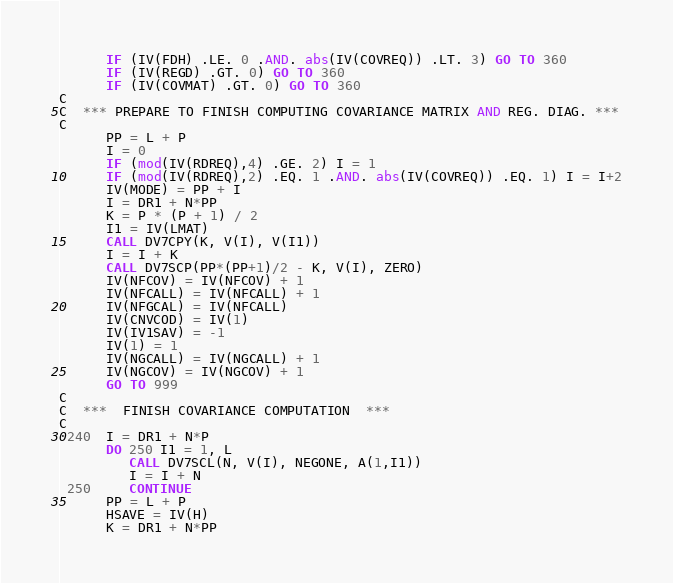Convert code to text. <code><loc_0><loc_0><loc_500><loc_500><_FORTRAN_>      IF (IV(FDH) .LE. 0 .AND. abs(IV(COVREQ)) .LT. 3) GO TO 360
      IF (IV(REGD) .GT. 0) GO TO 360
      IF (IV(COVMAT) .GT. 0) GO TO 360
C
C  *** PREPARE TO FINISH COMPUTING COVARIANCE MATRIX AND REG. DIAG. ***
C
      PP = L + P
      I = 0
      IF (mod(IV(RDREQ),4) .GE. 2) I = 1
      IF (mod(IV(RDREQ),2) .EQ. 1 .AND. abs(IV(COVREQ)) .EQ. 1) I = I+2
      IV(MODE) = PP + I
      I = DR1 + N*PP
      K = P * (P + 1) / 2
      I1 = IV(LMAT)
      CALL DV7CPY(K, V(I), V(I1))
      I = I + K
      CALL DV7SCP(PP*(PP+1)/2 - K, V(I), ZERO)
      IV(NFCOV) = IV(NFCOV) + 1
      IV(NFCALL) = IV(NFCALL) + 1
      IV(NFGCAL) = IV(NFCALL)
      IV(CNVCOD) = IV(1)
      IV(IV1SAV) = -1
      IV(1) = 1
      IV(NGCALL) = IV(NGCALL) + 1
      IV(NGCOV) = IV(NGCOV) + 1
      GO TO 999
C
C  ***  FINISH COVARIANCE COMPUTATION  ***
C
 240  I = DR1 + N*P
      DO 250 I1 = 1, L
         CALL DV7SCL(N, V(I), NEGONE, A(1,I1))
         I = I + N
 250     CONTINUE
      PP = L + P
      HSAVE = IV(H)
      K = DR1 + N*PP</code> 